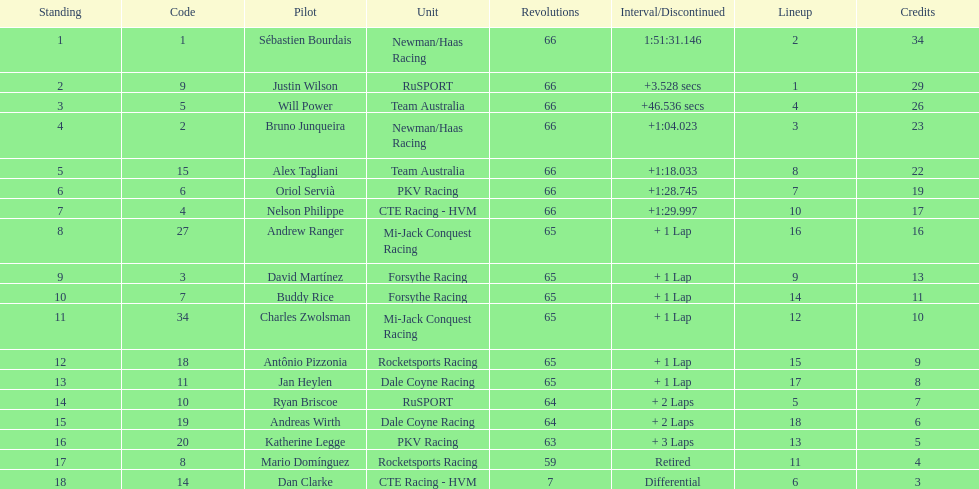Which country is represented by the most drivers? United Kingdom. 